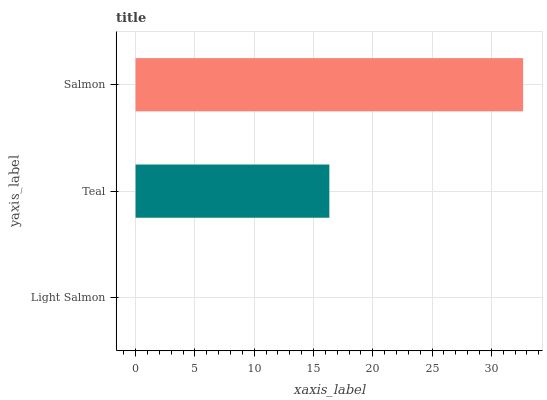Is Light Salmon the minimum?
Answer yes or no. Yes. Is Salmon the maximum?
Answer yes or no. Yes. Is Teal the minimum?
Answer yes or no. No. Is Teal the maximum?
Answer yes or no. No. Is Teal greater than Light Salmon?
Answer yes or no. Yes. Is Light Salmon less than Teal?
Answer yes or no. Yes. Is Light Salmon greater than Teal?
Answer yes or no. No. Is Teal less than Light Salmon?
Answer yes or no. No. Is Teal the high median?
Answer yes or no. Yes. Is Teal the low median?
Answer yes or no. Yes. Is Salmon the high median?
Answer yes or no. No. Is Salmon the low median?
Answer yes or no. No. 